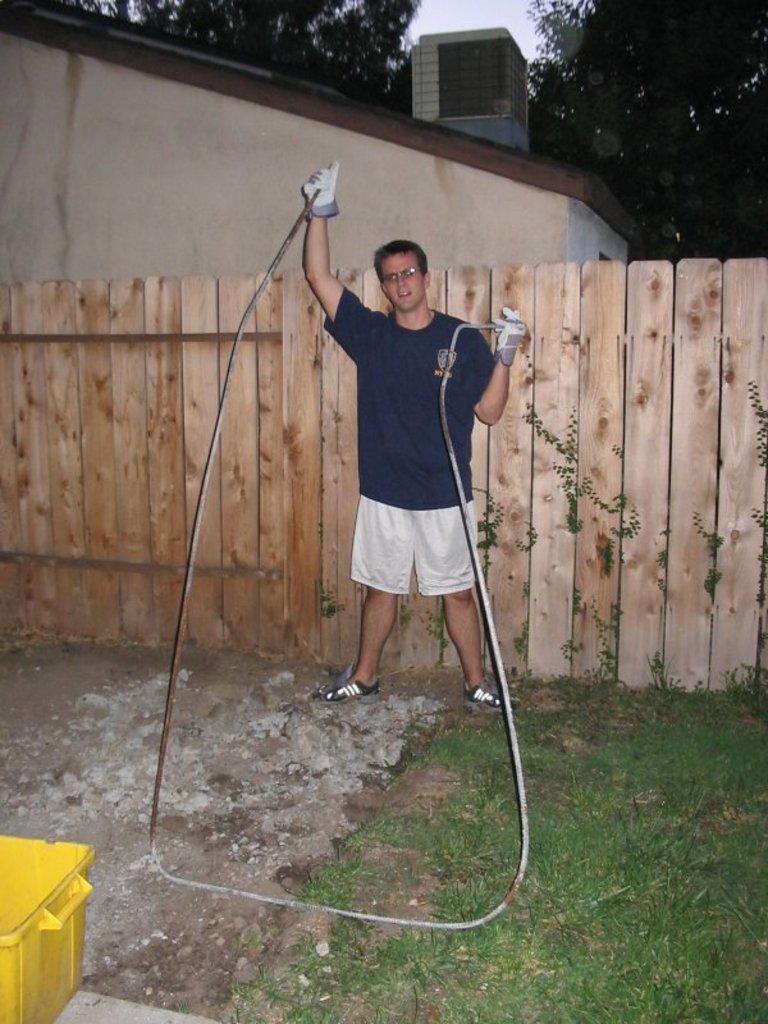Please provide a concise description of this image. In the image there is a man standing in front of a wooden fencing, there is some object in his hands and there is a grass on the right side. Behind the fencing there is a house and in the background there are few trees. 